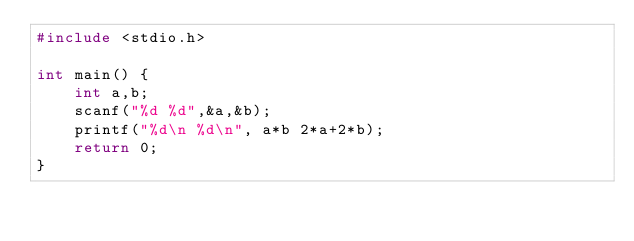Convert code to text. <code><loc_0><loc_0><loc_500><loc_500><_C_>#include <stdio.h>

int main() {
    int a,b;
    scanf("%d %d",&a,&b);
    printf("%d\n %d\n", a*b 2*a+2*b);
    return 0;
}</code> 